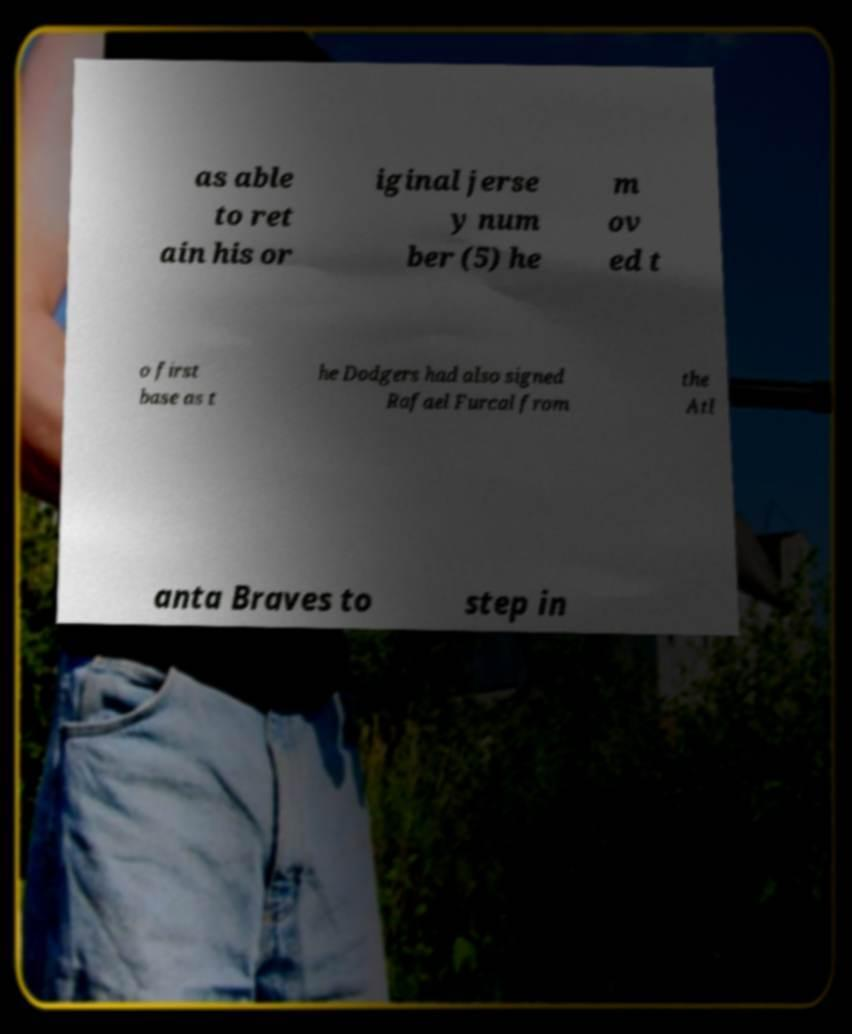Could you extract and type out the text from this image? as able to ret ain his or iginal jerse y num ber (5) he m ov ed t o first base as t he Dodgers had also signed Rafael Furcal from the Atl anta Braves to step in 